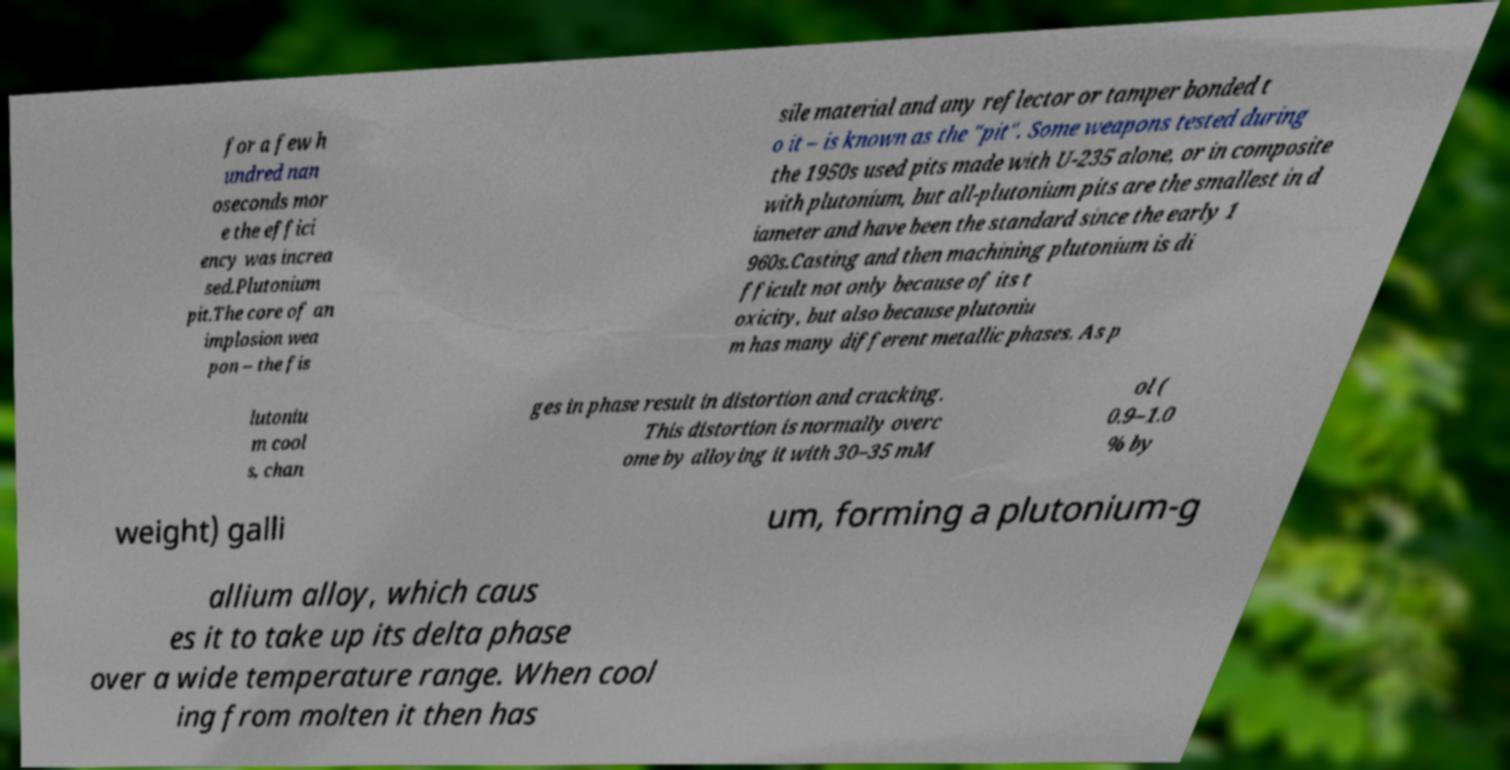There's text embedded in this image that I need extracted. Can you transcribe it verbatim? for a few h undred nan oseconds mor e the effici ency was increa sed.Plutonium pit.The core of an implosion wea pon – the fis sile material and any reflector or tamper bonded t o it – is known as the "pit". Some weapons tested during the 1950s used pits made with U-235 alone, or in composite with plutonium, but all-plutonium pits are the smallest in d iameter and have been the standard since the early 1 960s.Casting and then machining plutonium is di fficult not only because of its t oxicity, but also because plutoniu m has many different metallic phases. As p lutoniu m cool s, chan ges in phase result in distortion and cracking. This distortion is normally overc ome by alloying it with 30–35 mM ol ( 0.9–1.0 % by weight) galli um, forming a plutonium-g allium alloy, which caus es it to take up its delta phase over a wide temperature range. When cool ing from molten it then has 